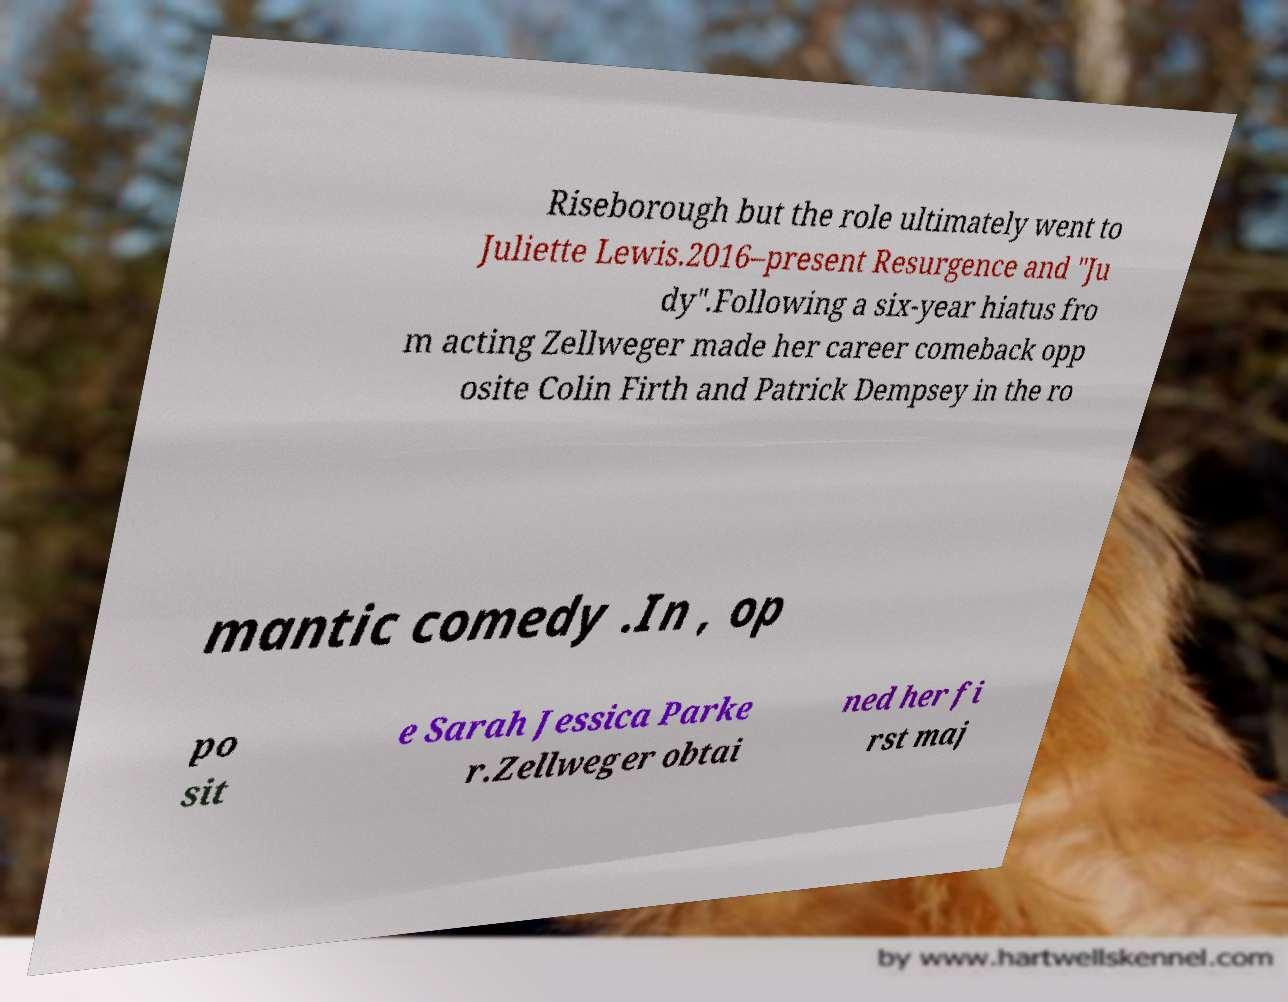Could you extract and type out the text from this image? Riseborough but the role ultimately went to Juliette Lewis.2016–present Resurgence and "Ju dy".Following a six-year hiatus fro m acting Zellweger made her career comeback opp osite Colin Firth and Patrick Dempsey in the ro mantic comedy .In , op po sit e Sarah Jessica Parke r.Zellweger obtai ned her fi rst maj 